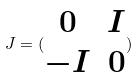<formula> <loc_0><loc_0><loc_500><loc_500>J = ( \begin{matrix} 0 & I \\ - I & 0 \end{matrix} )</formula> 